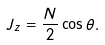<formula> <loc_0><loc_0><loc_500><loc_500>J _ { z } = \frac { N } { 2 } \cos \theta .</formula> 